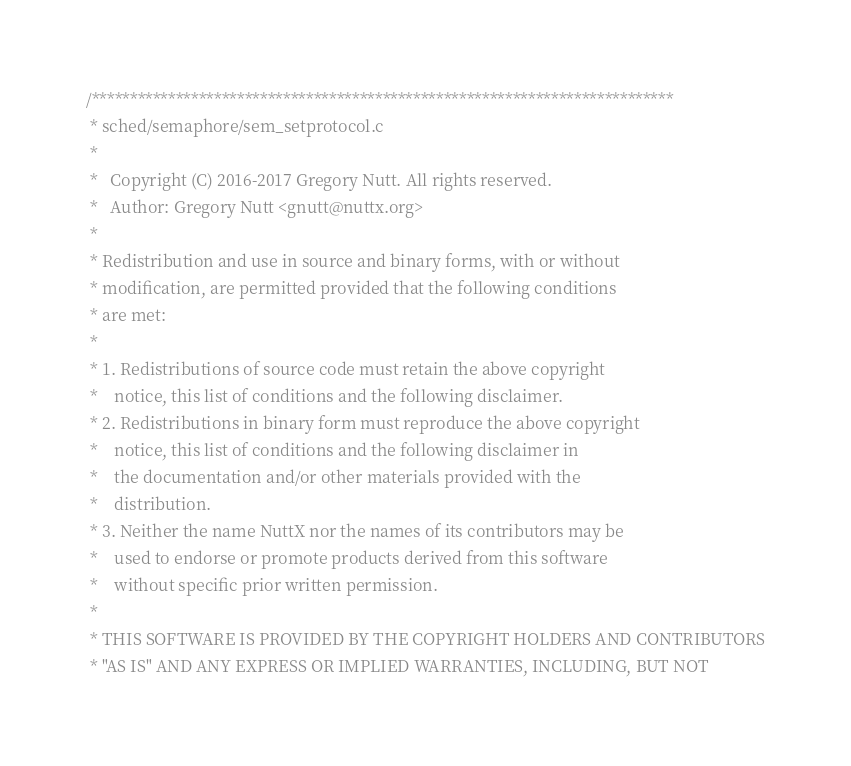Convert code to text. <code><loc_0><loc_0><loc_500><loc_500><_C_>/****************************************************************************
 * sched/semaphore/sem_setprotocol.c
 *
 *   Copyright (C) 2016-2017 Gregory Nutt. All rights reserved.
 *   Author: Gregory Nutt <gnutt@nuttx.org>
 *
 * Redistribution and use in source and binary forms, with or without
 * modification, are permitted provided that the following conditions
 * are met:
 *
 * 1. Redistributions of source code must retain the above copyright
 *    notice, this list of conditions and the following disclaimer.
 * 2. Redistributions in binary form must reproduce the above copyright
 *    notice, this list of conditions and the following disclaimer in
 *    the documentation and/or other materials provided with the
 *    distribution.
 * 3. Neither the name NuttX nor the names of its contributors may be
 *    used to endorse or promote products derived from this software
 *    without specific prior written permission.
 *
 * THIS SOFTWARE IS PROVIDED BY THE COPYRIGHT HOLDERS AND CONTRIBUTORS
 * "AS IS" AND ANY EXPRESS OR IMPLIED WARRANTIES, INCLUDING, BUT NOT</code> 